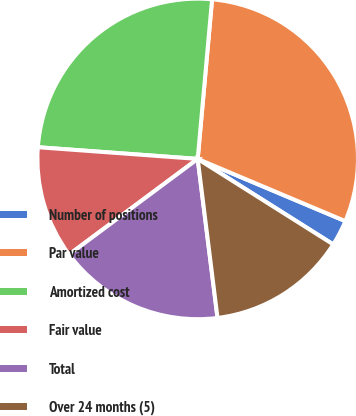<chart> <loc_0><loc_0><loc_500><loc_500><pie_chart><fcel>Number of positions<fcel>Par value<fcel>Amortized cost<fcel>Fair value<fcel>Total<fcel>Over 24 months (5)<nl><fcel>2.61%<fcel>29.92%<fcel>25.27%<fcel>11.34%<fcel>16.8%<fcel>14.07%<nl></chart> 